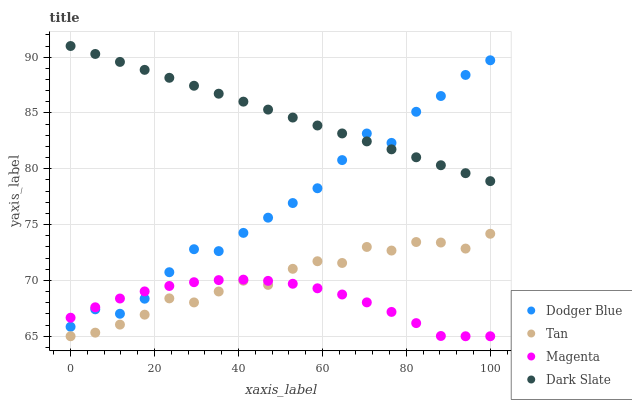Does Magenta have the minimum area under the curve?
Answer yes or no. Yes. Does Dark Slate have the maximum area under the curve?
Answer yes or no. Yes. Does Tan have the minimum area under the curve?
Answer yes or no. No. Does Tan have the maximum area under the curve?
Answer yes or no. No. Is Dark Slate the smoothest?
Answer yes or no. Yes. Is Dodger Blue the roughest?
Answer yes or no. Yes. Is Tan the smoothest?
Answer yes or no. No. Is Tan the roughest?
Answer yes or no. No. Does Tan have the lowest value?
Answer yes or no. Yes. Does Dodger Blue have the lowest value?
Answer yes or no. No. Does Dark Slate have the highest value?
Answer yes or no. Yes. Does Tan have the highest value?
Answer yes or no. No. Is Tan less than Dodger Blue?
Answer yes or no. Yes. Is Dark Slate greater than Tan?
Answer yes or no. Yes. Does Dodger Blue intersect Magenta?
Answer yes or no. Yes. Is Dodger Blue less than Magenta?
Answer yes or no. No. Is Dodger Blue greater than Magenta?
Answer yes or no. No. Does Tan intersect Dodger Blue?
Answer yes or no. No. 